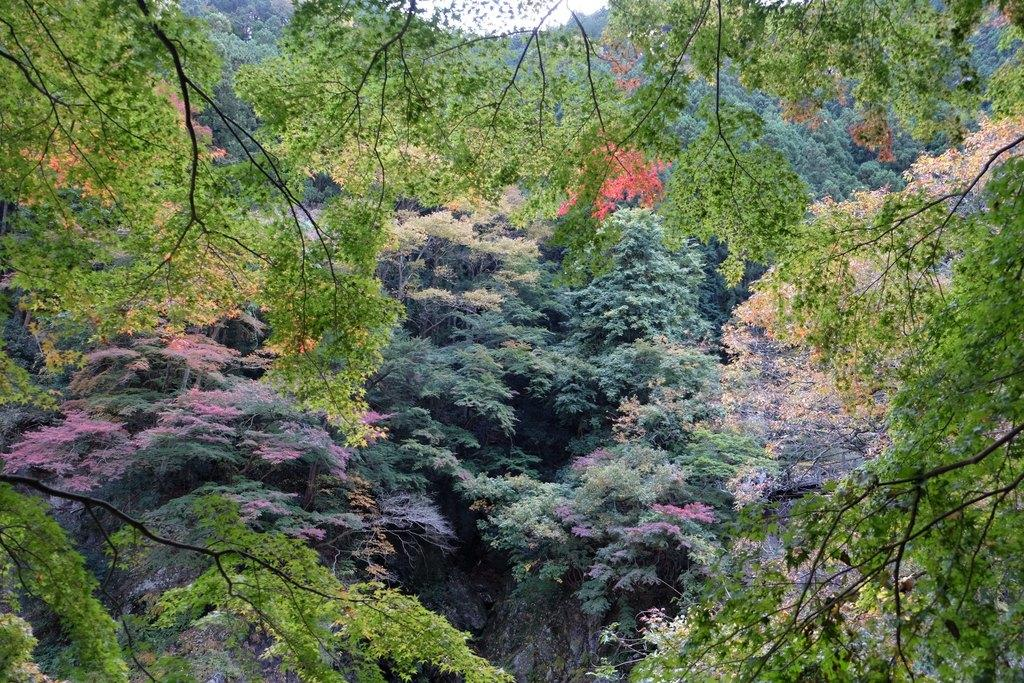What type of vegetation can be seen in the image? There are trees in the image. Where are the trees located in the image? The trees are present all over the image. What flavor of necklace can be seen hanging from the shelf in the image? There is no necklace or shelf present in the image; it only features trees. 